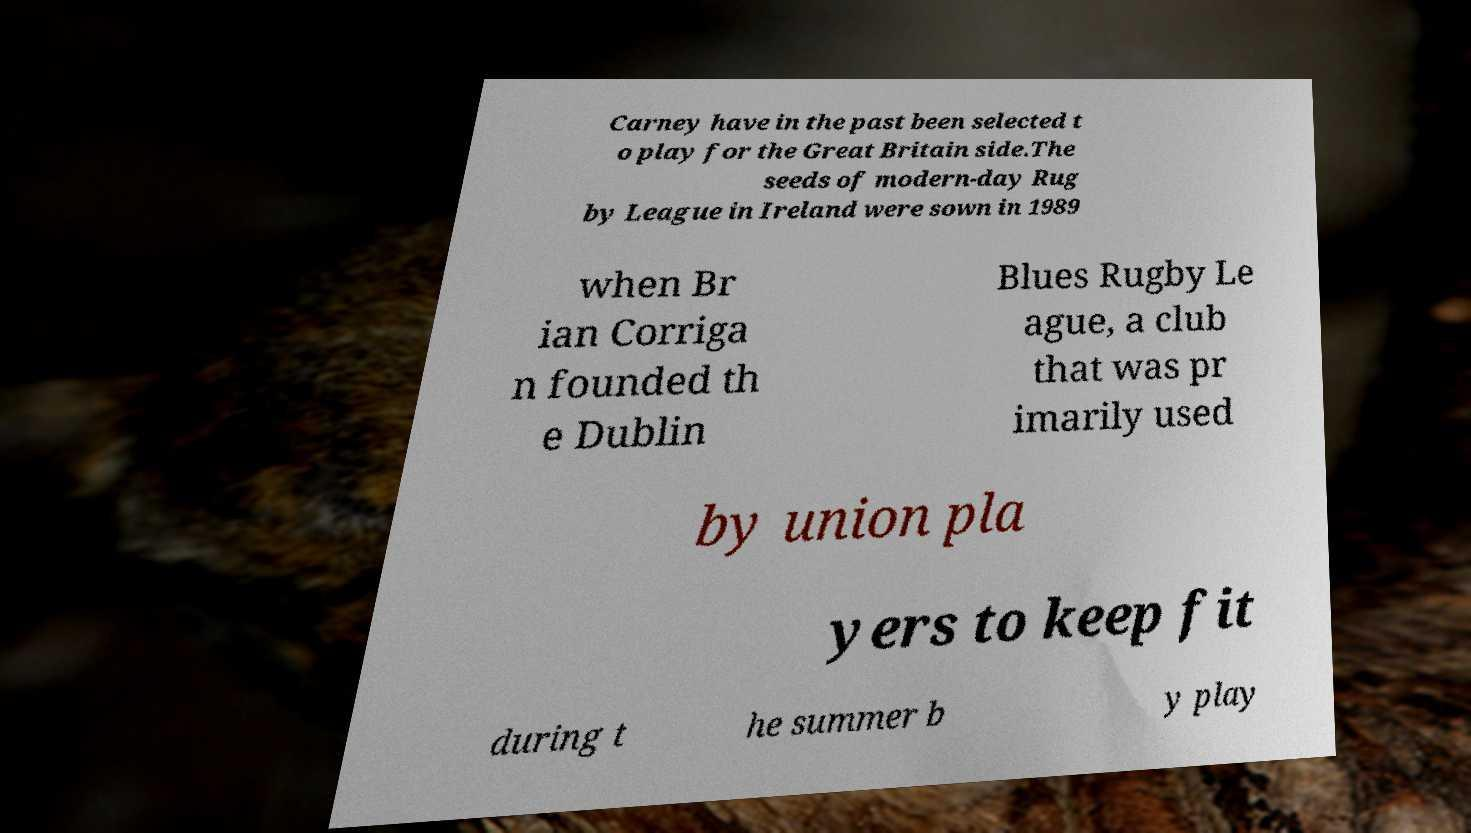I need the written content from this picture converted into text. Can you do that? Carney have in the past been selected t o play for the Great Britain side.The seeds of modern-day Rug by League in Ireland were sown in 1989 when Br ian Corriga n founded th e Dublin Blues Rugby Le ague, a club that was pr imarily used by union pla yers to keep fit during t he summer b y play 